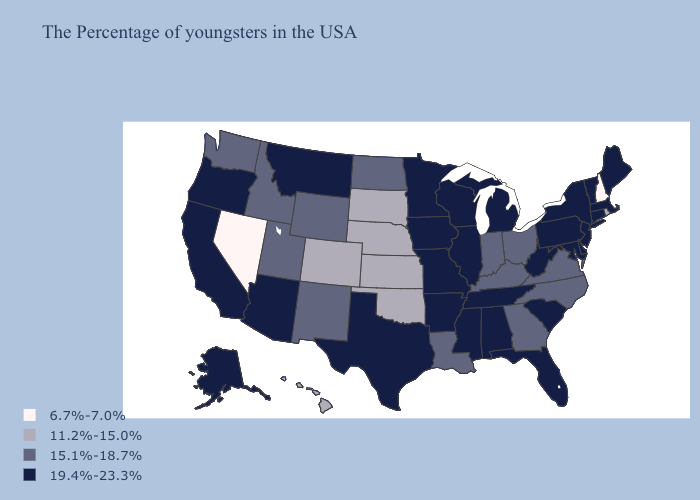Does Washington have the lowest value in the USA?
Answer briefly. No. Among the states that border Indiana , does Michigan have the lowest value?
Be succinct. No. Does Arizona have the lowest value in the West?
Concise answer only. No. Does Georgia have a lower value than Oklahoma?
Give a very brief answer. No. What is the lowest value in the MidWest?
Keep it brief. 11.2%-15.0%. Which states have the lowest value in the Northeast?
Write a very short answer. New Hampshire. How many symbols are there in the legend?
Write a very short answer. 4. Name the states that have a value in the range 19.4%-23.3%?
Write a very short answer. Maine, Massachusetts, Vermont, Connecticut, New York, New Jersey, Delaware, Maryland, Pennsylvania, South Carolina, West Virginia, Florida, Michigan, Alabama, Tennessee, Wisconsin, Illinois, Mississippi, Missouri, Arkansas, Minnesota, Iowa, Texas, Montana, Arizona, California, Oregon, Alaska. Which states have the highest value in the USA?
Keep it brief. Maine, Massachusetts, Vermont, Connecticut, New York, New Jersey, Delaware, Maryland, Pennsylvania, South Carolina, West Virginia, Florida, Michigan, Alabama, Tennessee, Wisconsin, Illinois, Mississippi, Missouri, Arkansas, Minnesota, Iowa, Texas, Montana, Arizona, California, Oregon, Alaska. What is the value of New Hampshire?
Short answer required. 6.7%-7.0%. Does Kansas have the same value as Georgia?
Give a very brief answer. No. Which states have the lowest value in the Northeast?
Answer briefly. New Hampshire. Name the states that have a value in the range 15.1%-18.7%?
Short answer required. Virginia, North Carolina, Ohio, Georgia, Kentucky, Indiana, Louisiana, North Dakota, Wyoming, New Mexico, Utah, Idaho, Washington. What is the lowest value in the USA?
Quick response, please. 6.7%-7.0%. Which states have the lowest value in the USA?
Answer briefly. New Hampshire, Nevada. 